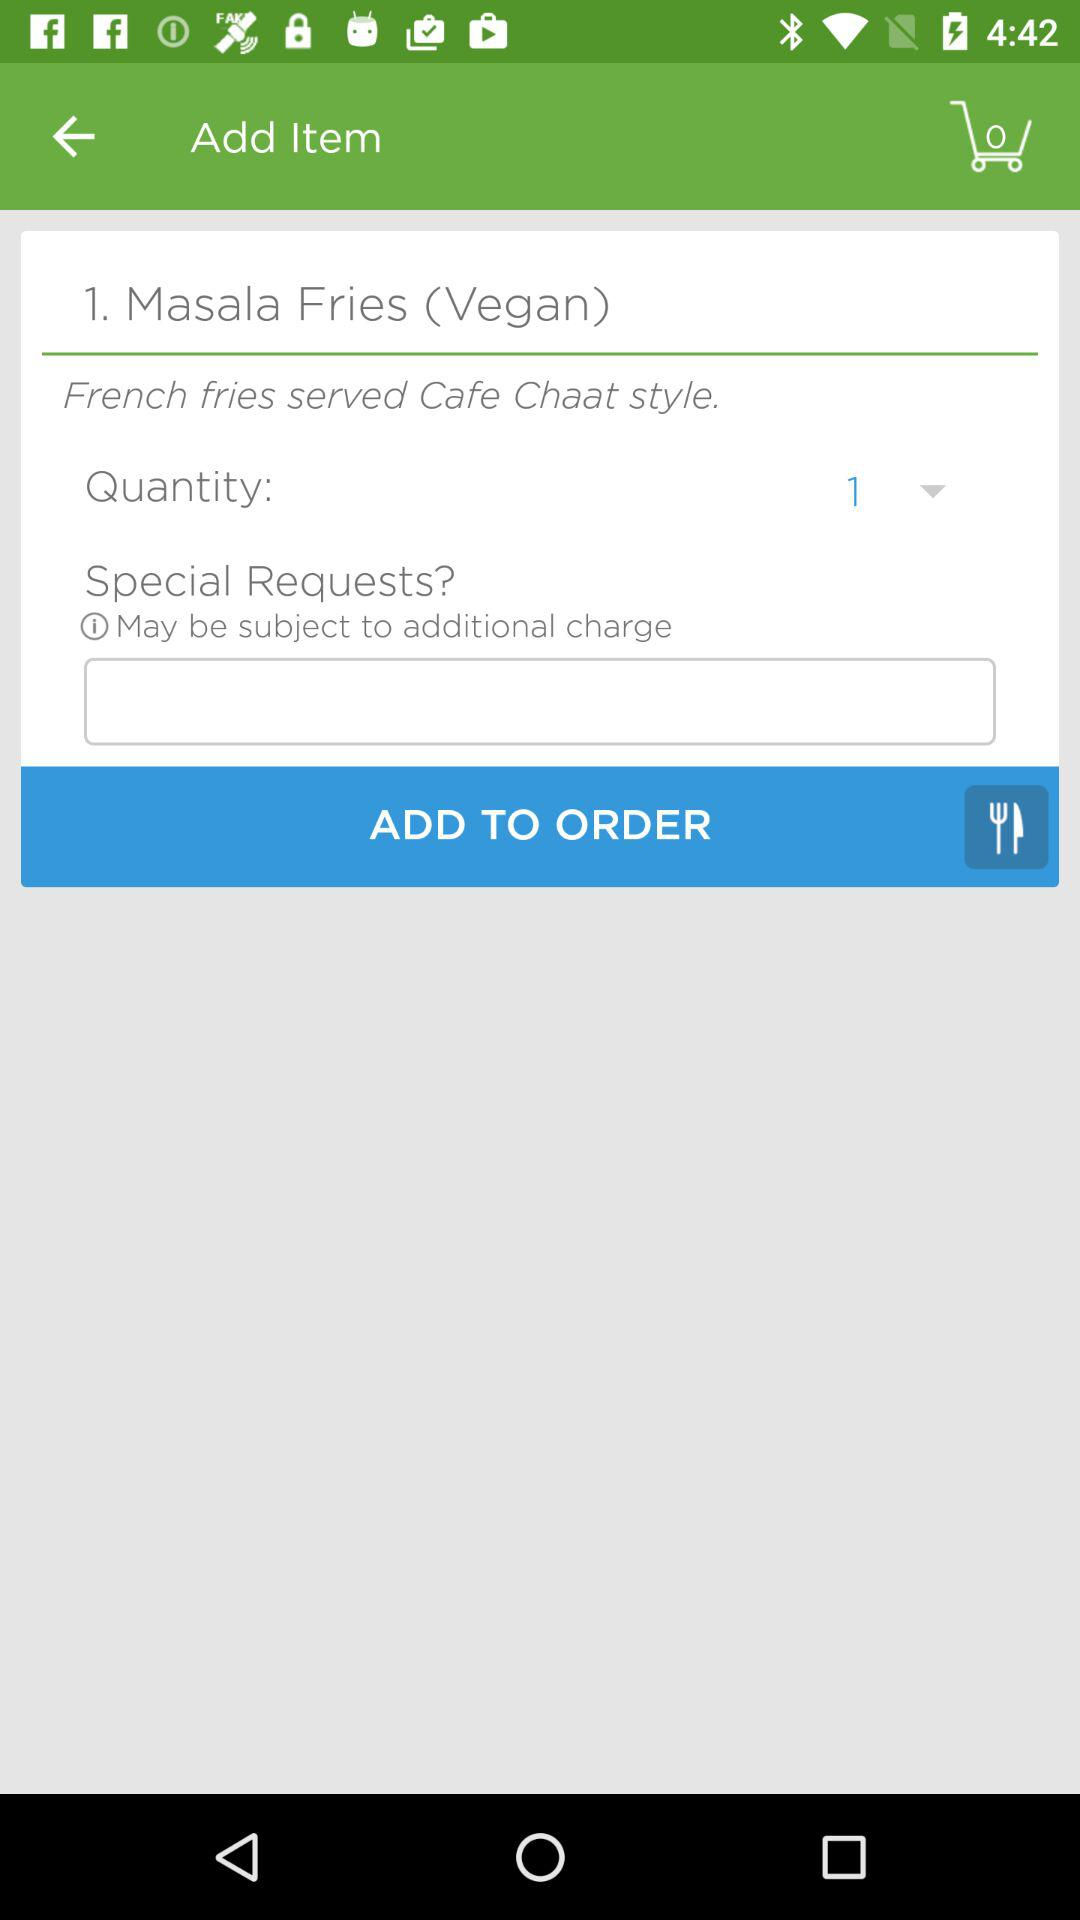What is the selected quantity? The selected quantity is 1. 